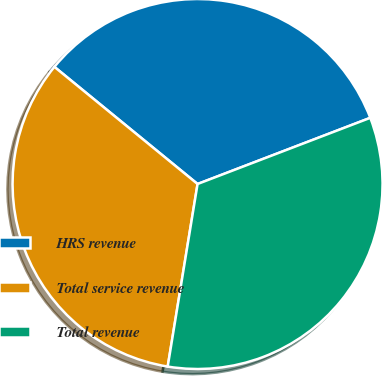<chart> <loc_0><loc_0><loc_500><loc_500><pie_chart><fcel>HRS revenue<fcel>Total service revenue<fcel>Total revenue<nl><fcel>33.26%<fcel>33.33%<fcel>33.4%<nl></chart> 